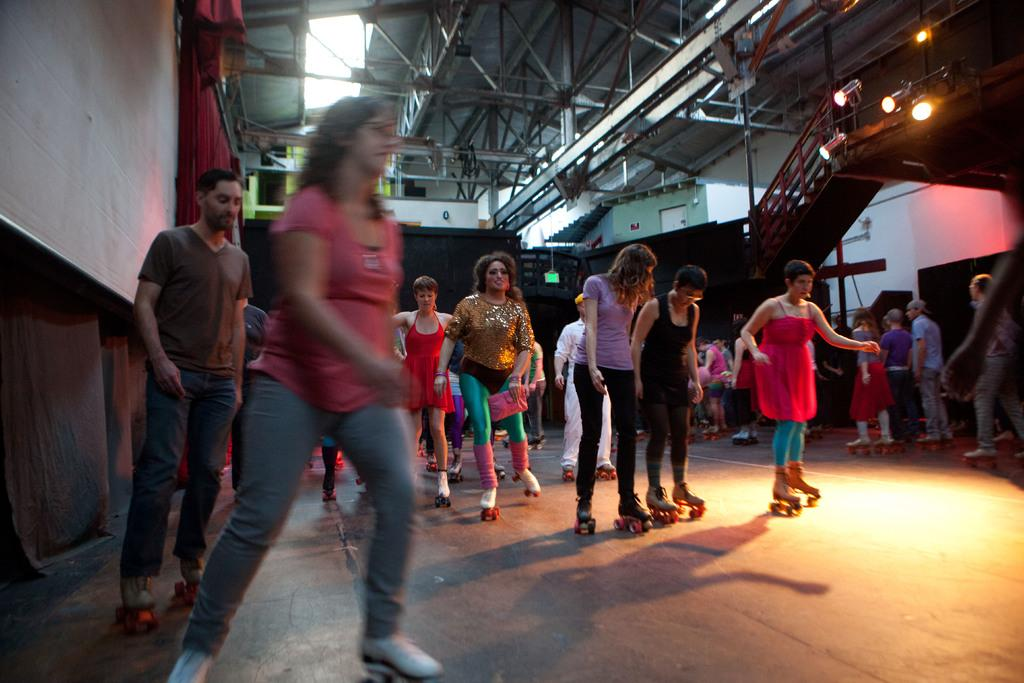What are the people in the image doing? The people in the image are skating on the floor. What else can be seen around the people skating? There are objects around the people skating. What type of window treatment is present in the image? There are curtains in the image. Can you describe any architectural features in the image? Yes, there are stairs in the image. What type of lighting is present in the image? There are lights in the image. What is visible at the top of the image? There is a ceiling visible at the top of the image. What type of book can be seen on the moon in the image? There is no moon or book present in the image; it features people skating on the floor with various objects and architectural features around them. 